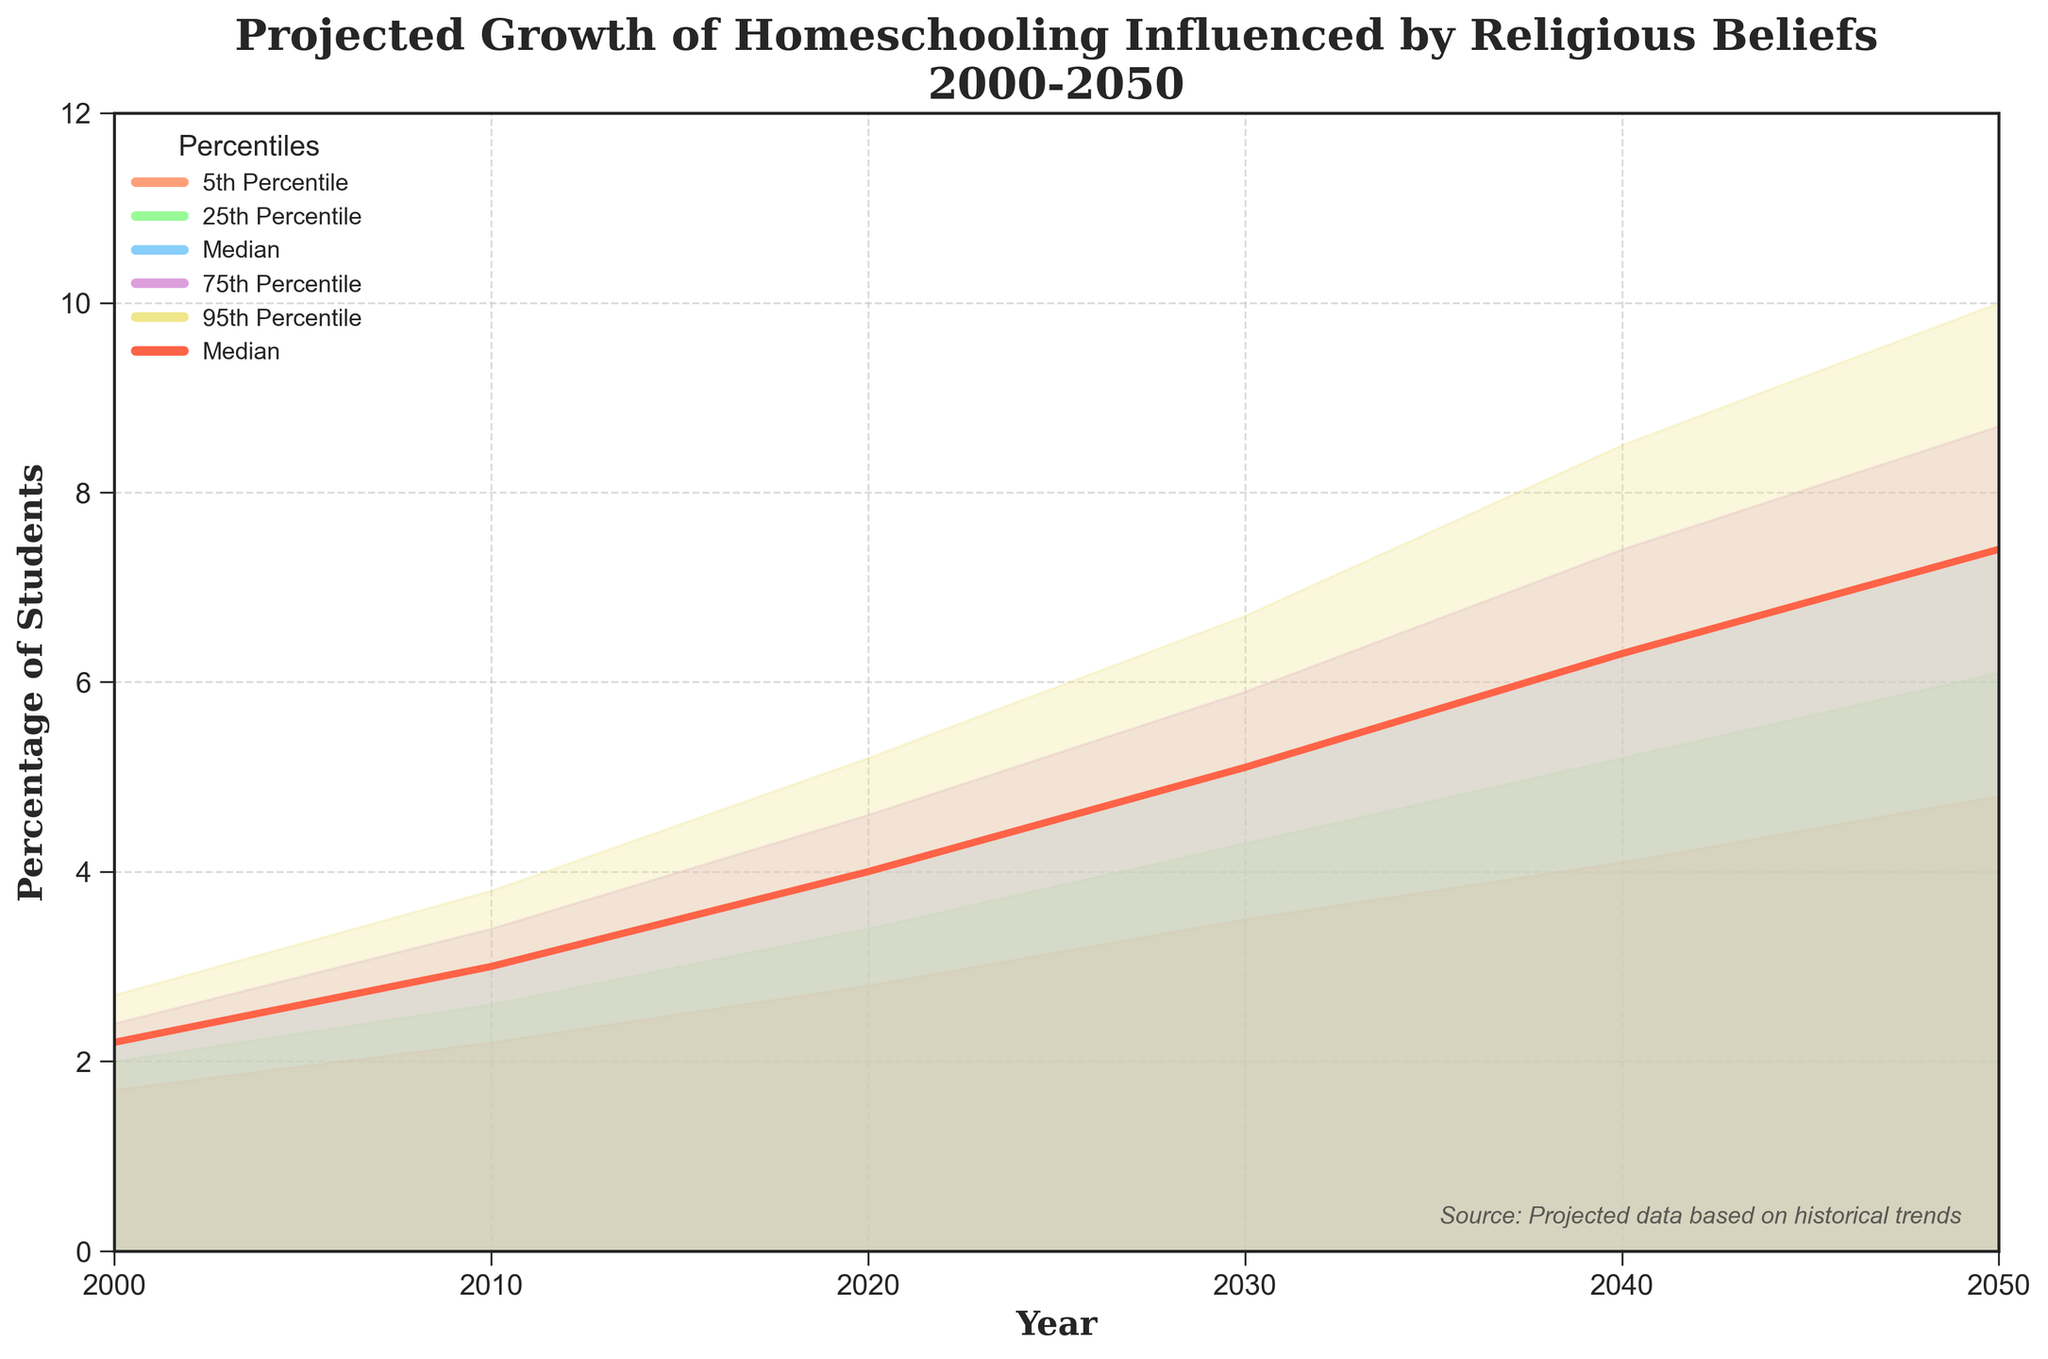What is the title of the figure? The title is located at the top of the figure, often highlighting the main topic it represents. Here, the title is "Projected Growth of Homeschooling Influenced by Religious Beliefs\n2000-2050."
Answer: Projected Growth of Homeschooling Influenced by Religious Beliefs\n2000-2050 What is the median projected percentage for homeschooling in 2020? To identify the median projected percentage for homeschooling in 2020, locate the year 2020 on the x-axis and find the corresponding median value, which is marked by the red line.
Answer: 4.0 What is the percentage difference between the 95th percentile and the 5th percentile in 2050? Find the projected values for the 95th and 5th percentiles in 2050. The values are 10.0 and 4.8, respectively. Subtract the 5th percentile value from the 95th percentile value: 10.0 - 4.8.
Answer: 5.2 How does the median value change from 2000 to 2050? Identify the median values for both 2000 and 2050. The values are 2.2 in 2000 and 7.4 in 2050. Subtract the 2000 median from the 2050 median: 7.4 - 2.2.
Answer: 5.2 Which percentile shows the highest projected increase from 2000 to 2050? Examine the percentiles (5th, 25th, median, 75th, 95th) for both 2000 and 2050. Calculate the increase for each by subtracting the 2000 value from the 2050 value. The 95th percentile increases from 2.7 to 10.0, which is the highest increase: 10.0 - 2.7.
Answer: 95th Percentile What is the range of the projected percentages for homeschooling in 2030? To find the range, identify the 5th and 95th percentile values for 2030. The values are 3.5 and 6.7, respectively. Subtract the 5th percentile value from the 95th percentile value: 6.7 - 3.5.
Answer: 3.2 At which year does the median projection first exceed 5%? Look at the median values plotted on the graph. Identify the first year where the median value exceeds 5%. This occurs in 2030 when the median is 5.1.
Answer: 2030 What is the projected 25th percentile in 2040, and how does it compare to the median in 2000? Locate the 25th percentile value for 2040, which is 5.2. Then, find the median value in 2000, which is 2.2. Compare the two values: 5.2 (25th percentile in 2040) and 2.2 (median in 2000). The 2040's 25th percentile is higher.
Answer: 5.2, higher Which percentile shows the smallest projected increase over the 50 years? Calculate the increase for each percentile from 2000 to 2050. For the 5th percentile, the increase is from 1.7 to 4.8, which is 3.1. This is compared to other percentiles, and the one with the smallest increase is the 5th percentile.
Answer: 5th Percentile 